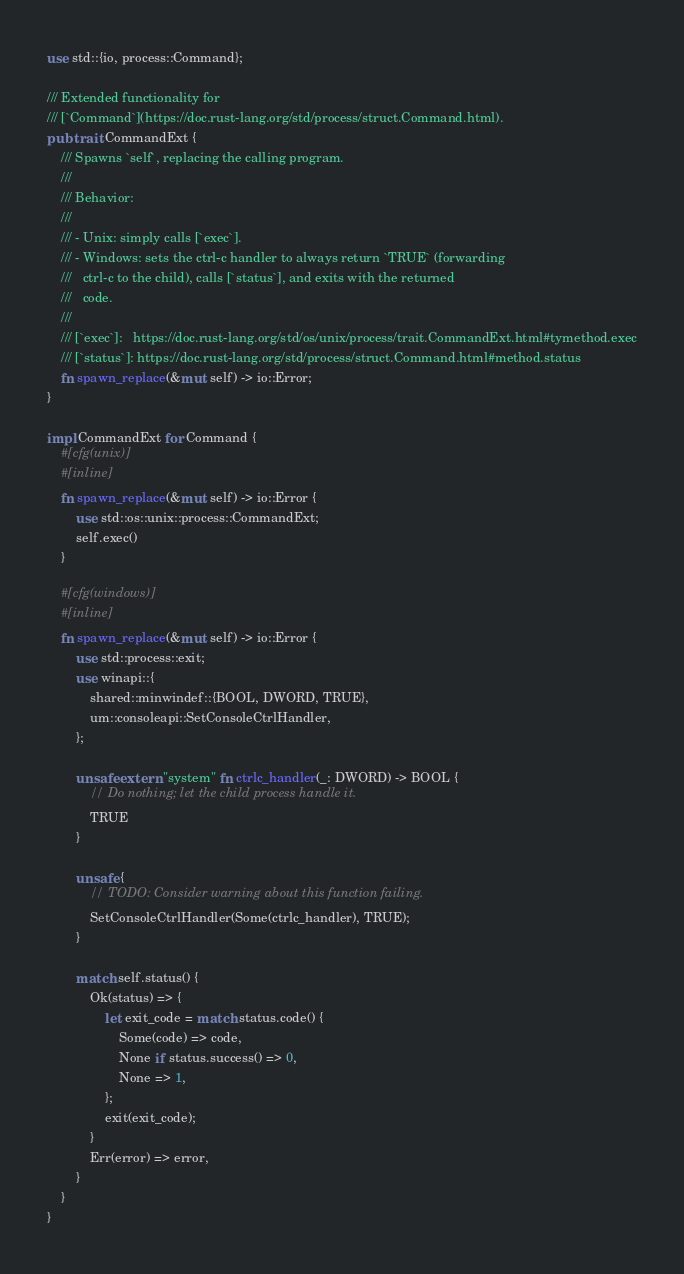<code> <loc_0><loc_0><loc_500><loc_500><_Rust_>use std::{io, process::Command};

/// Extended functionality for
/// [`Command`](https://doc.rust-lang.org/std/process/struct.Command.html).
pub trait CommandExt {
    /// Spawns `self`, replacing the calling program.
    ///
    /// Behavior:
    ///
    /// - Unix: simply calls [`exec`].
    /// - Windows: sets the ctrl-c handler to always return `TRUE` (forwarding
    ///   ctrl-c to the child), calls [`status`], and exits with the returned
    ///   code.
    ///
    /// [`exec`]:   https://doc.rust-lang.org/std/os/unix/process/trait.CommandExt.html#tymethod.exec
    /// [`status`]: https://doc.rust-lang.org/std/process/struct.Command.html#method.status
    fn spawn_replace(&mut self) -> io::Error;
}

impl CommandExt for Command {
    #[cfg(unix)]
    #[inline]
    fn spawn_replace(&mut self) -> io::Error {
        use std::os::unix::process::CommandExt;
        self.exec()
    }

    #[cfg(windows)]
    #[inline]
    fn spawn_replace(&mut self) -> io::Error {
        use std::process::exit;
        use winapi::{
            shared::minwindef::{BOOL, DWORD, TRUE},
            um::consoleapi::SetConsoleCtrlHandler,
        };

        unsafe extern "system" fn ctrlc_handler(_: DWORD) -> BOOL {
            // Do nothing; let the child process handle it.
            TRUE
        }

        unsafe {
            // TODO: Consider warning about this function failing.
            SetConsoleCtrlHandler(Some(ctrlc_handler), TRUE);
        }

        match self.status() {
            Ok(status) => {
                let exit_code = match status.code() {
                    Some(code) => code,
                    None if status.success() => 0,
                    None => 1,
                };
                exit(exit_code);
            }
            Err(error) => error,
        }
    }
}
</code> 